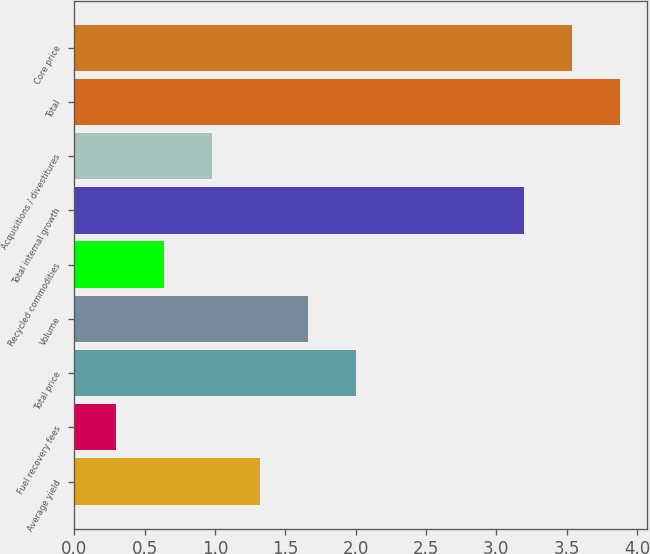Convert chart to OTSL. <chart><loc_0><loc_0><loc_500><loc_500><bar_chart><fcel>Average yield<fcel>Fuel recovery fees<fcel>Total price<fcel>Volume<fcel>Recycled commodities<fcel>Total internal growth<fcel>Acquisitions / divestitures<fcel>Total<fcel>Core price<nl><fcel>1.32<fcel>0.3<fcel>2<fcel>1.66<fcel>0.64<fcel>3.2<fcel>0.98<fcel>3.88<fcel>3.54<nl></chart> 